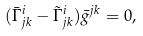Convert formula to latex. <formula><loc_0><loc_0><loc_500><loc_500>( \bar { \Gamma } ^ { i } _ { j k } - \tilde { \Gamma } ^ { i } _ { j k } ) \bar { g } ^ { j k } = 0 ,</formula> 